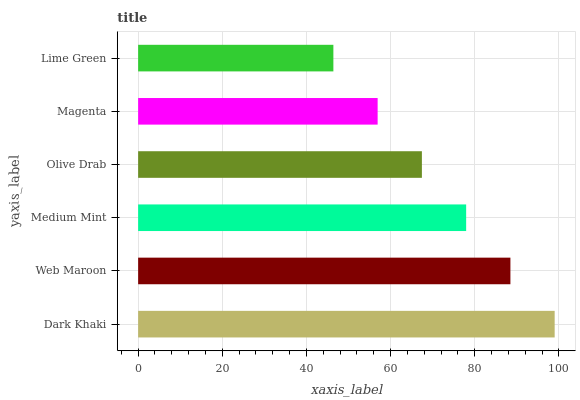Is Lime Green the minimum?
Answer yes or no. Yes. Is Dark Khaki the maximum?
Answer yes or no. Yes. Is Web Maroon the minimum?
Answer yes or no. No. Is Web Maroon the maximum?
Answer yes or no. No. Is Dark Khaki greater than Web Maroon?
Answer yes or no. Yes. Is Web Maroon less than Dark Khaki?
Answer yes or no. Yes. Is Web Maroon greater than Dark Khaki?
Answer yes or no. No. Is Dark Khaki less than Web Maroon?
Answer yes or no. No. Is Medium Mint the high median?
Answer yes or no. Yes. Is Olive Drab the low median?
Answer yes or no. Yes. Is Dark Khaki the high median?
Answer yes or no. No. Is Medium Mint the low median?
Answer yes or no. No. 